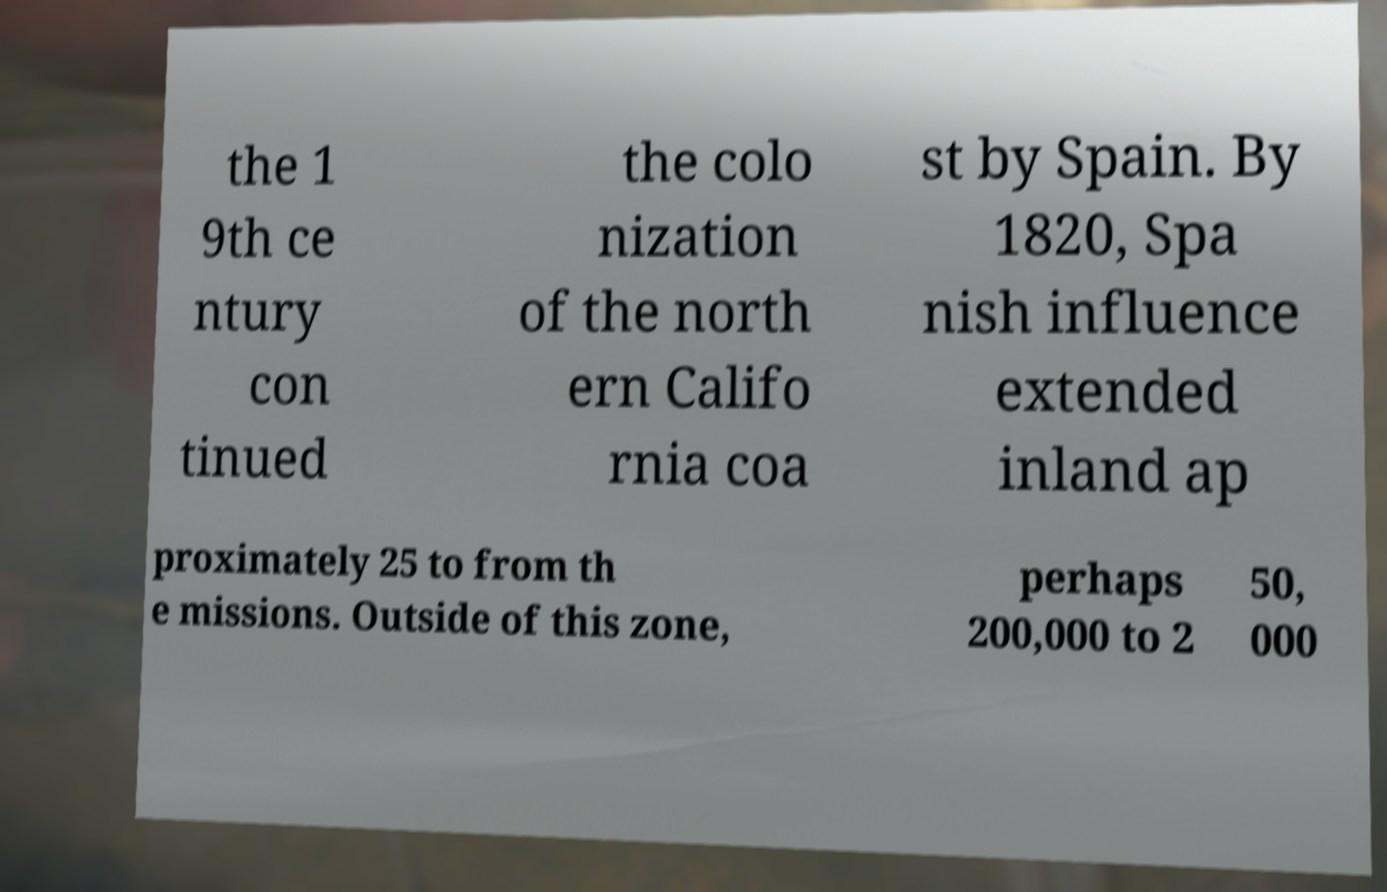Can you read and provide the text displayed in the image?This photo seems to have some interesting text. Can you extract and type it out for me? the 1 9th ce ntury con tinued the colo nization of the north ern Califo rnia coa st by Spain. By 1820, Spa nish influence extended inland ap proximately 25 to from th e missions. Outside of this zone, perhaps 200,000 to 2 50, 000 